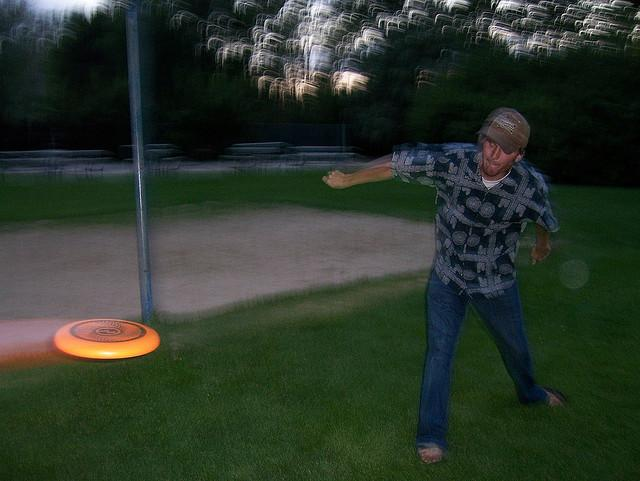In which type space does this man spin his frisbee? park 